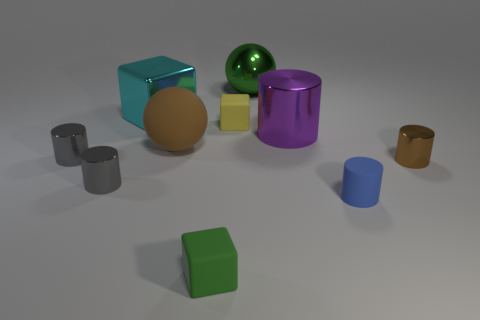Subtract all small rubber cylinders. How many cylinders are left? 4 Subtract all cubes. How many objects are left? 7 Subtract 3 blocks. How many blocks are left? 0 Subtract all brown balls. How many balls are left? 1 Subtract 1 purple cylinders. How many objects are left? 9 Subtract all blue spheres. Subtract all red blocks. How many spheres are left? 2 Subtract all brown cubes. How many red balls are left? 0 Subtract all tiny shiny things. Subtract all metal spheres. How many objects are left? 6 Add 2 large metal blocks. How many large metal blocks are left? 3 Add 9 big rubber balls. How many big rubber balls exist? 10 